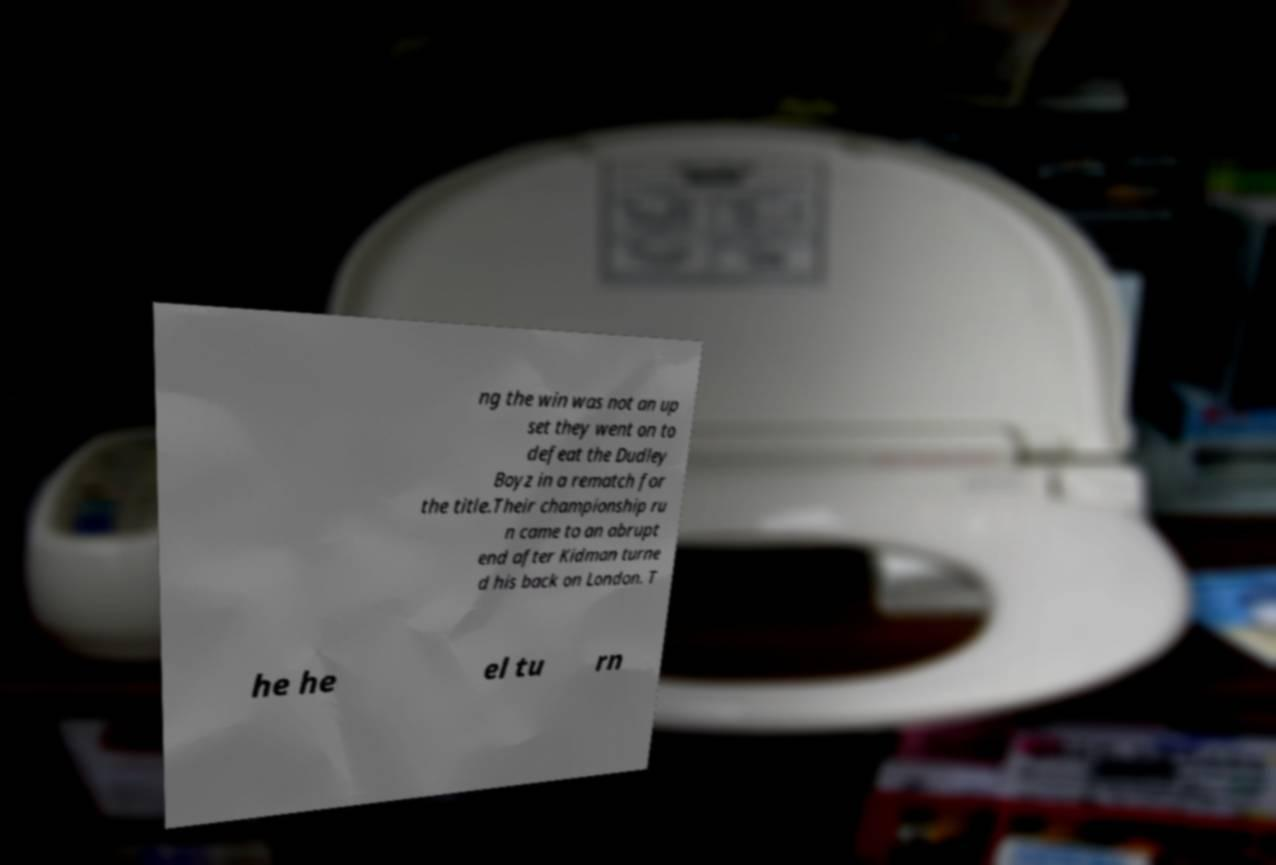I need the written content from this picture converted into text. Can you do that? ng the win was not an up set they went on to defeat the Dudley Boyz in a rematch for the title.Their championship ru n came to an abrupt end after Kidman turne d his back on London. T he he el tu rn 